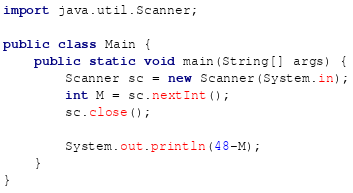Convert code to text. <code><loc_0><loc_0><loc_500><loc_500><_Java_>import java.util.Scanner;

public class Main {
	public static void main(String[] args) {
		Scanner sc = new Scanner(System.in);
		int M = sc.nextInt();
		sc.close();
		
		System.out.println(48-M);
	}
}
</code> 